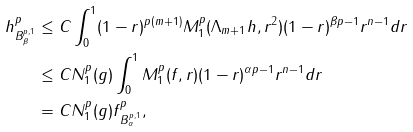<formula> <loc_0><loc_0><loc_500><loc_500>\| h \| _ { B ^ { p , 1 } _ { \beta } } ^ { p } & \leq C \int _ { 0 } ^ { 1 } ( 1 - r ) ^ { p ( m + 1 ) } M _ { 1 } ^ { p } ( \Lambda _ { m + 1 } h , r ^ { 2 } ) ( 1 - r ) ^ { \beta p - 1 } r ^ { n - 1 } d r \\ & \leq C N _ { 1 } ^ { p } ( g ) \int _ { 0 } ^ { 1 } M _ { 1 } ^ { p } ( f , r ) ( 1 - r ) ^ { \alpha p - 1 } r ^ { n - 1 } d r \\ & = C N _ { 1 } ^ { p } ( g ) \| f \| _ { B ^ { p , 1 } _ { \alpha } } ^ { p } ,</formula> 